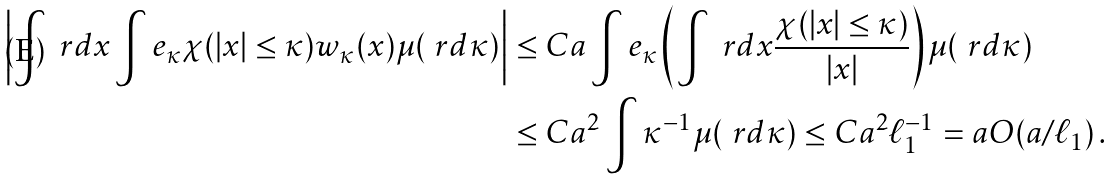<formula> <loc_0><loc_0><loc_500><loc_500>\left | \int \ r d x \int e _ { \kappa } \chi ( | x | \leq \kappa ) w _ { \kappa } ( x ) \mu ( \ r d \kappa ) \right | & \leq C a \int e _ { \kappa } \left ( \int \ r d x \frac { \chi ( | x | \leq \kappa ) } { | x | } \right ) \mu ( \ r d \kappa ) \\ & \leq C a ^ { 2 } \int \kappa ^ { - 1 } \mu ( \ r d \kappa ) \leq C a ^ { 2 } \ell _ { 1 } ^ { - 1 } = a O ( a / \ell _ { 1 } ) \, .</formula> 